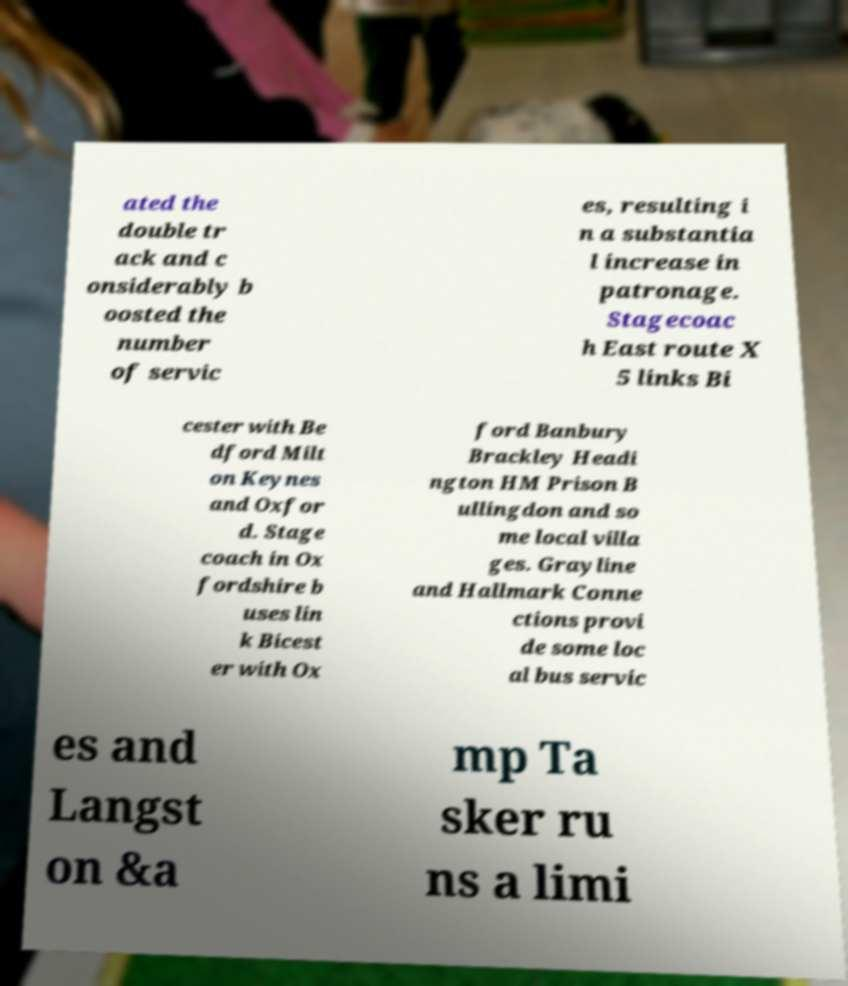Could you assist in decoding the text presented in this image and type it out clearly? ated the double tr ack and c onsiderably b oosted the number of servic es, resulting i n a substantia l increase in patronage. Stagecoac h East route X 5 links Bi cester with Be dford Milt on Keynes and Oxfor d. Stage coach in Ox fordshire b uses lin k Bicest er with Ox ford Banbury Brackley Headi ngton HM Prison B ullingdon and so me local villa ges. Grayline and Hallmark Conne ctions provi de some loc al bus servic es and Langst on &a mp Ta sker ru ns a limi 